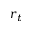<formula> <loc_0><loc_0><loc_500><loc_500>r _ { t }</formula> 